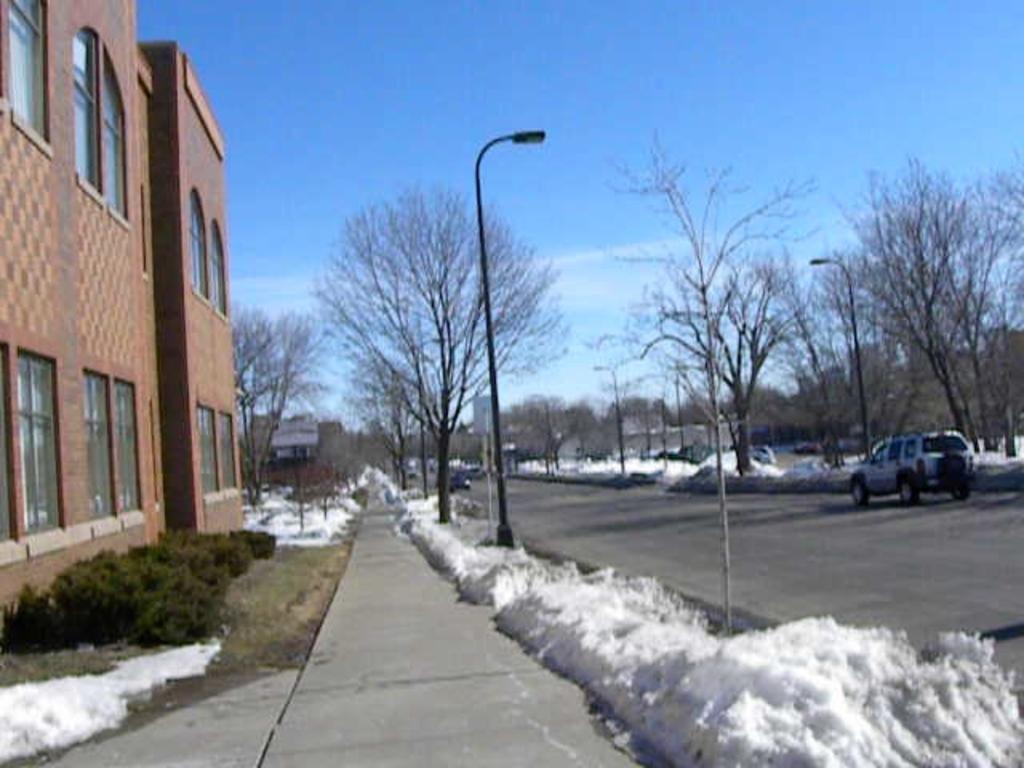Can you describe this image briefly? On the left side of the image we can see a building with windows and group of plants. To the right side of the image we can see vehicles parked on the road, a group of street lights and trees. In the background we can see the sky. 